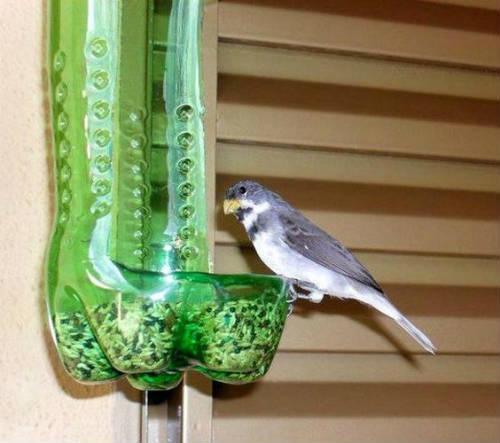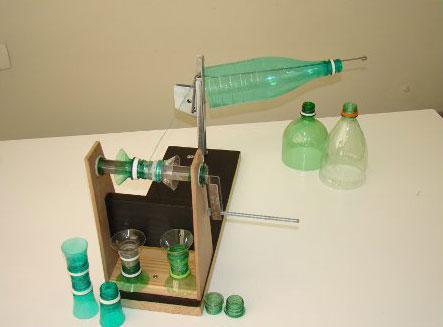The first image is the image on the left, the second image is the image on the right. For the images shown, is this caption "The right image shows something holding a green bottle horizontally with its top end to the right." true? Answer yes or no. Yes. The first image is the image on the left, the second image is the image on the right. Evaluate the accuracy of this statement regarding the images: "In one of the images, the plastic bottles have been remade into containers that look like apples.". Is it true? Answer yes or no. No. 